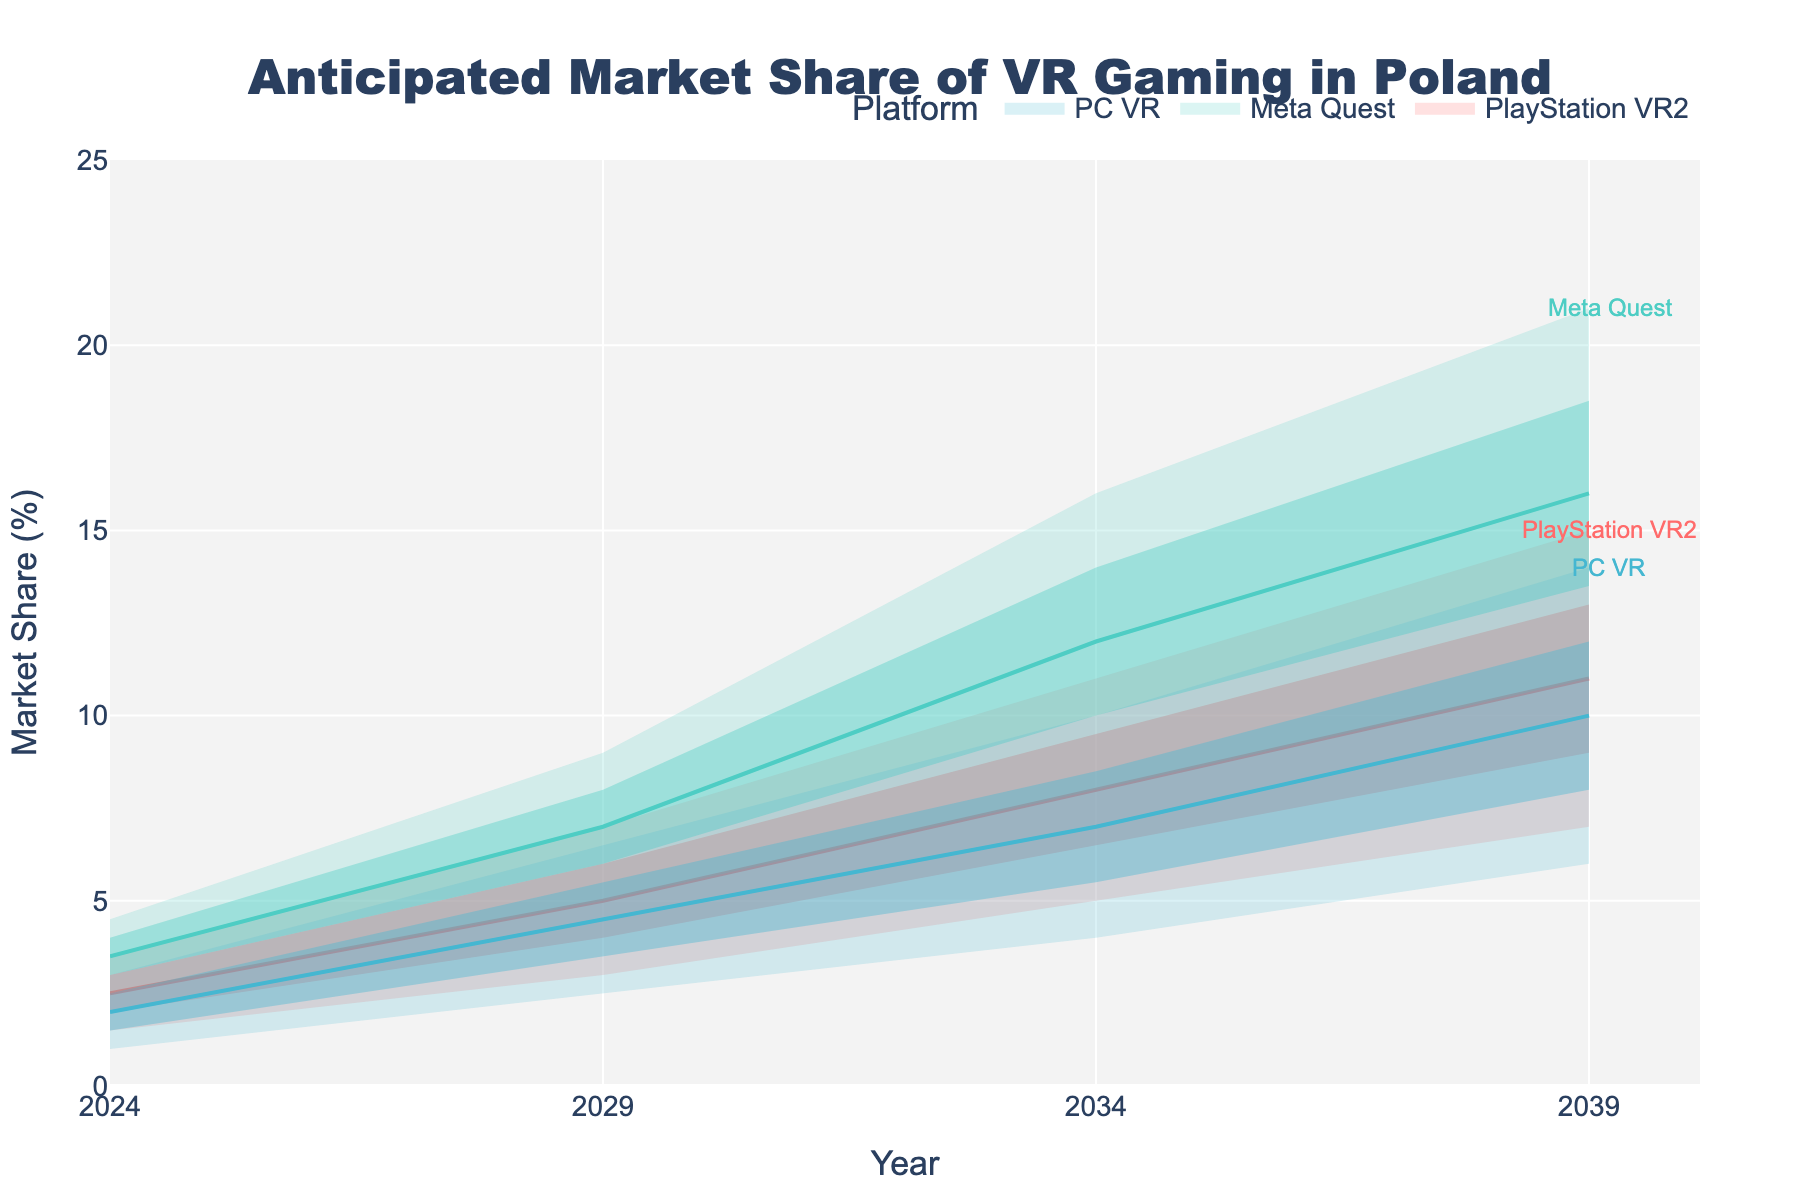What is the title of the figure? The title is usually located at the top of the figure. In this case, it is stated in the code that the title is "Anticipated Market Share of VR Gaming in Poland".
Answer: Anticipated Market Share of VR Gaming in Poland What are the platforms shown in the figure? The figure distinguishes market share data by platform. The platforms listed in the data are "PlayStation VR2", "Meta Quest", and "PC VR".
Answer: PlayStation VR2, Meta Quest, PC VR How does the market share of PlayStation VR2 change from 2024 to 2039? Look at the middle line for PlayStation VR2 in the figure. In 2024, it starts at 2.5%, increases to 5% in 2029, 8% in 2034, and reaches 11% by 2039.
Answer: It increases from 2.5% to 11% What is the anticipated market share range of Meta Quest in 2034? In 2034, look at the lower, lower middle, middle, upper middle, and upper lines for Meta Quest. They are 8%, 10%, 12%, 14%, and 16%, respectively.
Answer: 8% to 16% Which platform has the highest middle market share value in 2029? Compare the middle values for each platform in 2029. PlayStation VR2 is 5%, Meta Quest is 7%, and PC VR is 4.5%. Meta Quest has the highest middle value.
Answer: Meta Quest How does the variability in market share projections change for PlayStation VR2 from 2024 to 2039? The variability can be assessed by the range between the lower and upper bounds. For PlayStation VR2, in 2024 this range is 2% (3.5% - 1.5%), in 2029 it is 4% (7% - 3%), in 2034 it is 6% (11% - 5%), and in 2039 it is 8% (15% - 7%). The range increases over time.
Answer: It increases over time In which year does PC VR reach a market share of at least 10% in its upper projection? Look at the upper line for PC VR until it crosses 10%. This happens in 2034 where the upper projected value is 10%.
Answer: 2034 Between 2029 and 2034, which platform shows the greatest increase in middle market share? Compare the increase in the middle values between 2029 and 2034. PlayStation VR2 increases by 3% (8% - 5%), Meta Quest increases by 5% (12% - 7%), and PC VR increases by 2.5% (7% - 4.5%). Meta Quest has the greatest increase.
Answer: Meta Quest What is the anticipated market share range for PC VR in 2039? In 2039, look at the lower, lower middle, middle, upper middle, and upper lines for PC VR. They are 6%, 8%, 10%, 12%, and 14% respectively.
Answer: 6% to 14% 